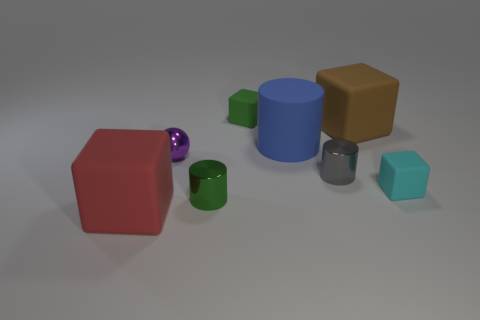Is the material of the small green object in front of the brown matte block the same as the big block in front of the small shiny sphere?
Ensure brevity in your answer.  No. Are there any other things that are the same shape as the big red object?
Your answer should be compact. Yes. Do the small gray thing and the large cube that is behind the red rubber thing have the same material?
Give a very brief answer. No. There is a tiny cylinder on the left side of the green object behind the big cube behind the large red rubber block; what is its color?
Ensure brevity in your answer.  Green. What is the shape of the matte object that is the same size as the green block?
Your answer should be compact. Cube. Is there any other thing that has the same size as the gray cylinder?
Your answer should be compact. Yes. There is a matte thing that is left of the green rubber block; does it have the same size as the metallic cylinder that is on the right side of the green cube?
Provide a short and direct response. No. There is a shiny cylinder that is on the left side of the matte cylinder; what size is it?
Ensure brevity in your answer.  Small. What color is the rubber cylinder that is the same size as the red thing?
Your answer should be very brief. Blue. Is the metal ball the same size as the cyan thing?
Give a very brief answer. Yes. 